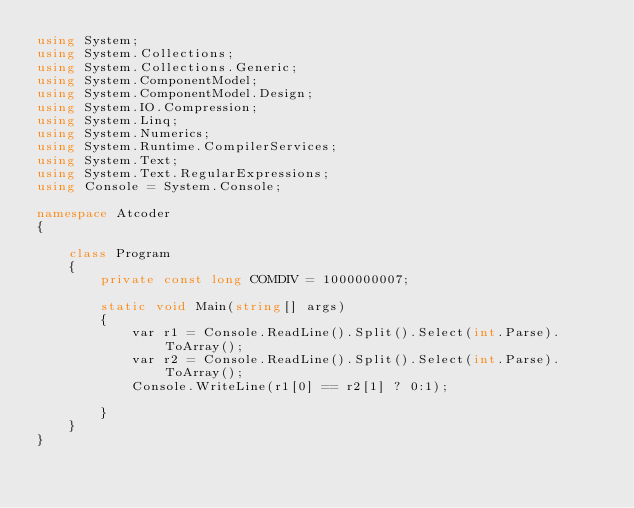Convert code to text. <code><loc_0><loc_0><loc_500><loc_500><_C#_>using System;
using System.Collections;
using System.Collections.Generic;
using System.ComponentModel;
using System.ComponentModel.Design;
using System.IO.Compression;
using System.Linq;
using System.Numerics;
using System.Runtime.CompilerServices;
using System.Text;
using System.Text.RegularExpressions;
using Console = System.Console;

namespace Atcoder
{

    class Program
    {
        private const long COMDIV = 1000000007;

        static void Main(string[] args)
        {
            var r1 = Console.ReadLine().Split().Select(int.Parse).ToArray();
            var r2 = Console.ReadLine().Split().Select(int.Parse).ToArray();
            Console.WriteLine(r1[0] == r2[1] ? 0:1);

        }
    }
}</code> 